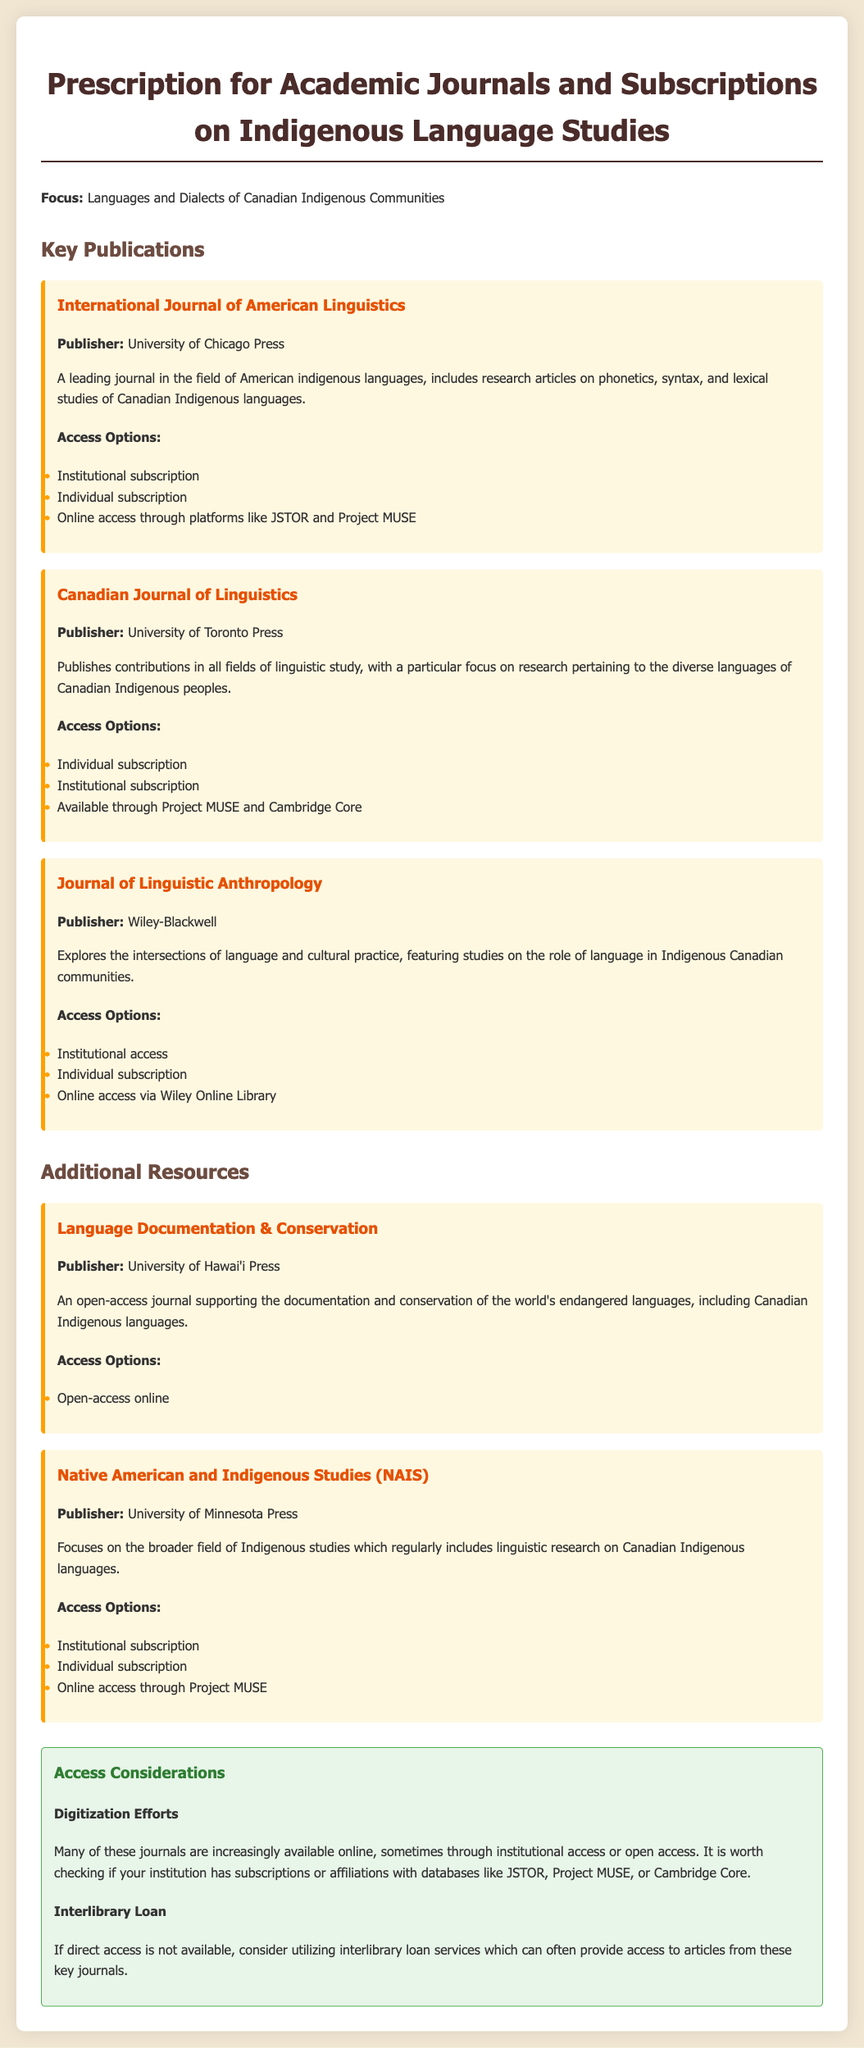What is the title of the document? The title of the document is explicitly stated at the beginning, which is "Prescription for Academic Journals and Subscriptions on Indigenous Language Studies".
Answer: Prescription for Academic Journals and Subscriptions on Indigenous Language Studies Who publishes the International Journal of American Linguistics? The publisher is mentioned in the document, which is the University of Chicago Press.
Answer: University of Chicago Press What type of access is available for Language Documentation & Conservation? The document states that it is available as an open-access journal.
Answer: Open-access online Which journal focuses on the intersections of language and cultural practice? The document indicates that "Journal of Linguistic Anthropology" explores these intersections.
Answer: Journal of Linguistic Anthropology How many access options are listed for the Canadian Journal of Linguistics? The document lists three access options available for this journal.
Answer: Three What is the main focus of the Native American and Indigenous Studies (NAIS) journal? It is described in the document that NAIS focuses on the broader field of Indigenous studies, including linguistic research.
Answer: Indigenous studies Is access through JSTOR available for the International Journal of American Linguistics? The document confirms access through platforms like JSTOR.
Answer: Yes What consideration is offered for accessing articles if direct access is unavailable? The document suggests using interlibrary loan services for access to articles.
Answer: Interlibrary loan services 